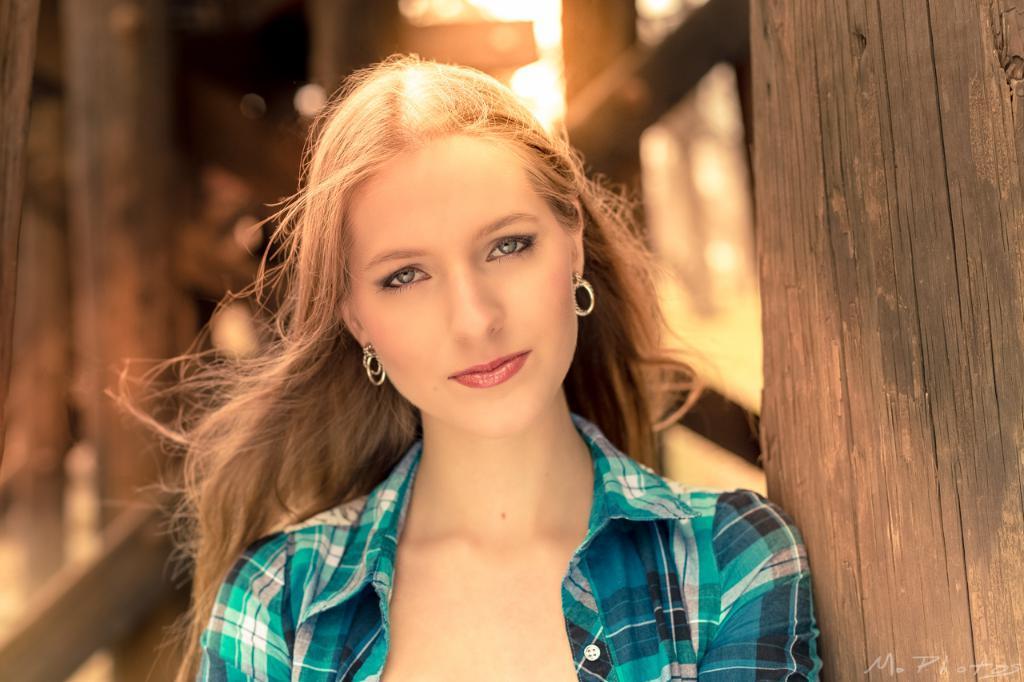Could you give a brief overview of what you see in this image? In this picture I can see a woman and I can see wood on the right side and I can see blurry background and I can see text at the bottom right corner of the picture. 